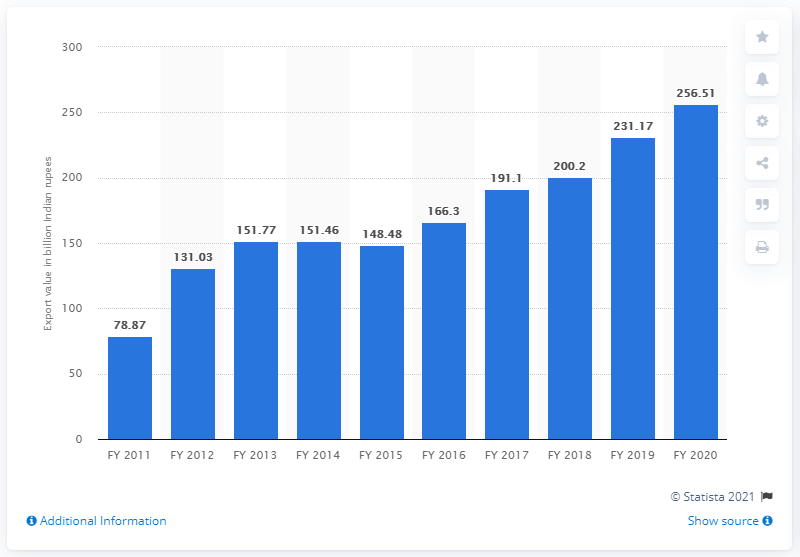Give some essential details in this illustration. The export value of spices from India in the fiscal year 2020 was 256.51 million. 